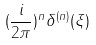<formula> <loc_0><loc_0><loc_500><loc_500>( \frac { i } { 2 \pi } ) ^ { n } \delta ^ { ( n ) } ( \xi )</formula> 